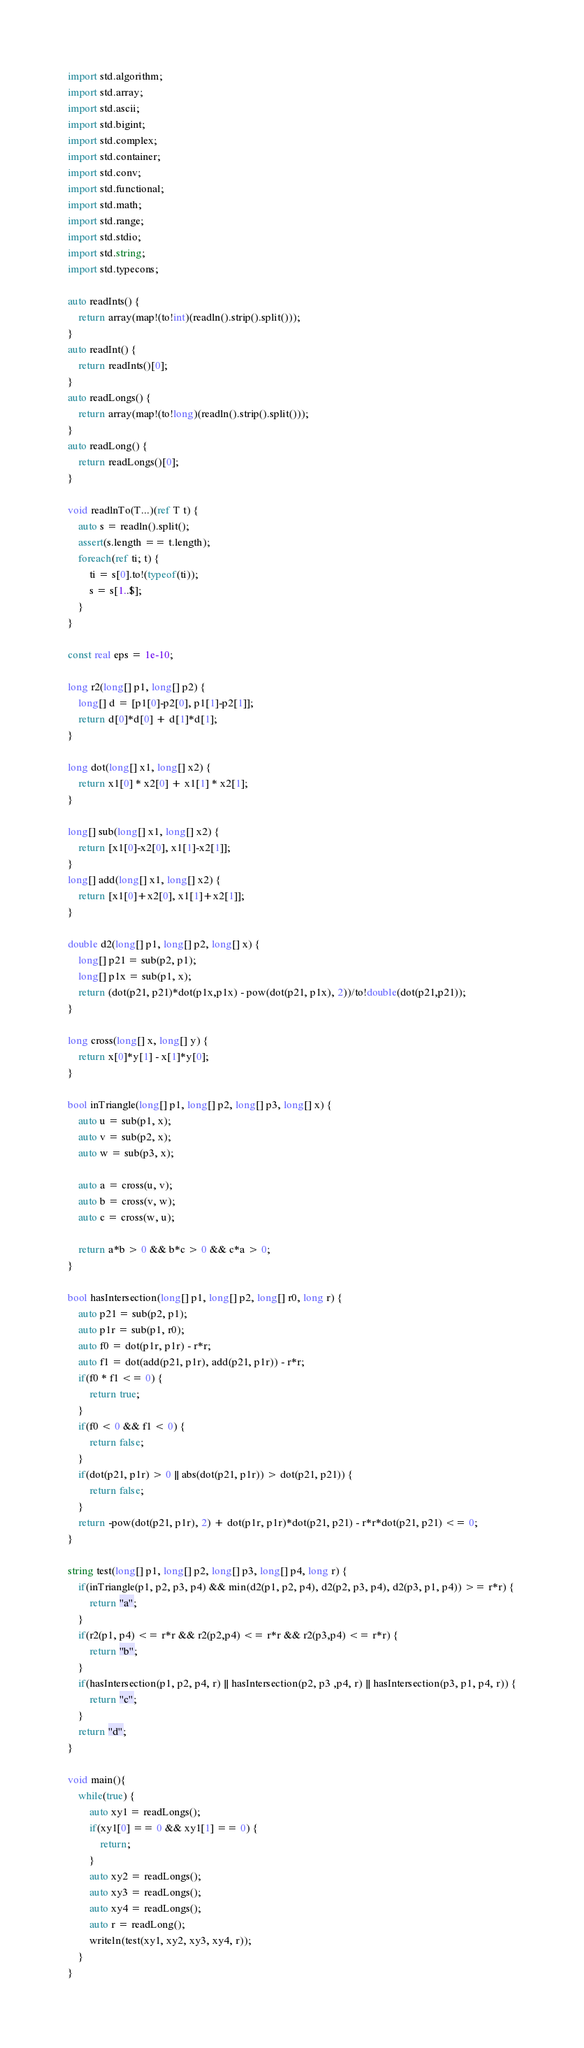<code> <loc_0><loc_0><loc_500><loc_500><_D_>import std.algorithm;
import std.array;
import std.ascii;
import std.bigint;
import std.complex;
import std.container;
import std.conv;
import std.functional;
import std.math;
import std.range;
import std.stdio;
import std.string;
import std.typecons;

auto readInts() {
	return array(map!(to!int)(readln().strip().split()));
}
auto readInt() {
	return readInts()[0];
}
auto readLongs() {
	return array(map!(to!long)(readln().strip().split()));
}
auto readLong() {
	return readLongs()[0];
}

void readlnTo(T...)(ref T t) {
    auto s = readln().split();
    assert(s.length == t.length);
    foreach(ref ti; t) {
        ti = s[0].to!(typeof(ti));
        s = s[1..$];
    }
}

const real eps = 1e-10;

long r2(long[] p1, long[] p2) {
    long[] d = [p1[0]-p2[0], p1[1]-p2[1]];
    return d[0]*d[0] + d[1]*d[1];
}

long dot(long[] x1, long[] x2) {
    return x1[0] * x2[0] + x1[1] * x2[1];
}

long[] sub(long[] x1, long[] x2) {
    return [x1[0]-x2[0], x1[1]-x2[1]];
}
long[] add(long[] x1, long[] x2) {
    return [x1[0]+x2[0], x1[1]+x2[1]];
}

double d2(long[] p1, long[] p2, long[] x) {
    long[] p21 = sub(p2, p1);
    long[] p1x = sub(p1, x);
    return (dot(p21, p21)*dot(p1x,p1x) - pow(dot(p21, p1x), 2))/to!double(dot(p21,p21));
}

long cross(long[] x, long[] y) {
    return x[0]*y[1] - x[1]*y[0];
}

bool inTriangle(long[] p1, long[] p2, long[] p3, long[] x) {
    auto u = sub(p1, x);
    auto v = sub(p2, x);
    auto w = sub(p3, x);
    
    auto a = cross(u, v);
    auto b = cross(v, w);
    auto c = cross(w, u);

    return a*b > 0 && b*c > 0 && c*a > 0;
}

bool hasIntersection(long[] p1, long[] p2, long[] r0, long r) {
    auto p21 = sub(p2, p1);
    auto p1r = sub(p1, r0);
    auto f0 = dot(p1r, p1r) - r*r;
    auto f1 = dot(add(p21, p1r), add(p21, p1r)) - r*r;
    if(f0 * f1 <= 0) {
        return true;
    }
    if(f0 < 0 && f1 < 0) {
        return false;
    }
    if(dot(p21, p1r) > 0 || abs(dot(p21, p1r)) > dot(p21, p21)) {
        return false;
    }
    return -pow(dot(p21, p1r), 2) + dot(p1r, p1r)*dot(p21, p21) - r*r*dot(p21, p21) <= 0;
}

string test(long[] p1, long[] p2, long[] p3, long[] p4, long r) {
    if(inTriangle(p1, p2, p3, p4) && min(d2(p1, p2, p4), d2(p2, p3, p4), d2(p3, p1, p4)) >= r*r) {
        return "a";
    }
    if(r2(p1, p4) <= r*r && r2(p2,p4) <= r*r && r2(p3,p4) <= r*r) {
        return "b";
    }
    if(hasIntersection(p1, p2, p4, r) || hasIntersection(p2, p3 ,p4, r) || hasIntersection(p3, p1, p4, r)) {
        return "c";
    }
    return "d";
}

void main(){
    while(true) {
        auto xy1 = readLongs();
        if(xy1[0] == 0 && xy1[1] == 0) {
            return;
        }
        auto xy2 = readLongs();
        auto xy3 = readLongs();
        auto xy4 = readLongs();
        auto r = readLong();
        writeln(test(xy1, xy2, xy3, xy4, r));
    }
}</code> 